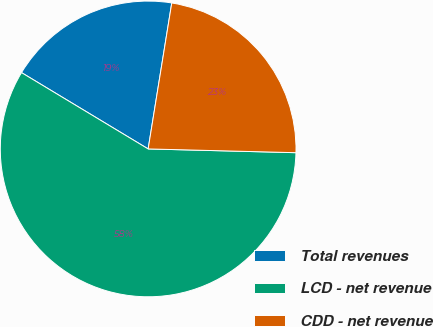Convert chart. <chart><loc_0><loc_0><loc_500><loc_500><pie_chart><fcel>Total revenues<fcel>LCD - net revenue<fcel>CDD - net revenue<nl><fcel>18.92%<fcel>58.22%<fcel>22.85%<nl></chart> 